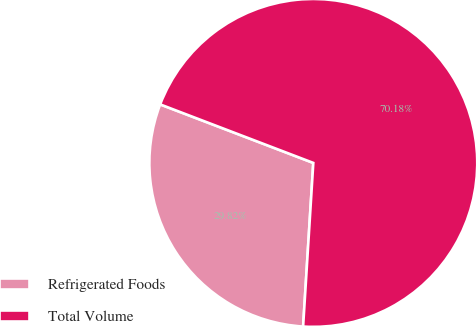Convert chart to OTSL. <chart><loc_0><loc_0><loc_500><loc_500><pie_chart><fcel>Refrigerated Foods<fcel>Total Volume<nl><fcel>29.82%<fcel>70.18%<nl></chart> 